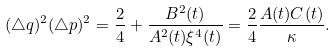Convert formula to latex. <formula><loc_0><loc_0><loc_500><loc_500>( \triangle q ) ^ { 2 } ( \triangle p ) ^ { 2 } = \frac { 2 } { 4 } + \frac { B ^ { 2 } ( t ) } { A ^ { 2 } ( t ) \xi ^ { 4 } ( t ) } = \frac { 2 } { 4 } \frac { A ( t ) C ( t ) } { \kappa } .</formula> 